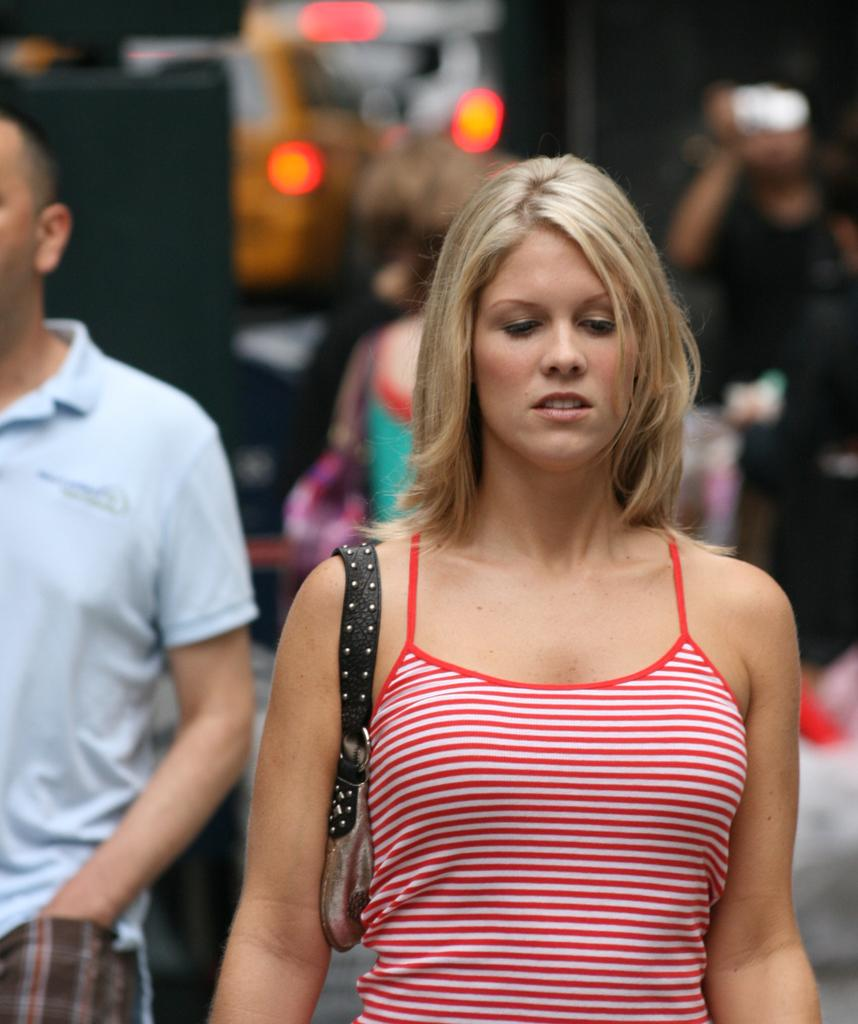Who is present in the image? There is a woman and a man in the image. What is the woman wearing? The woman is wearing a red dress. What is the man wearing? The man is wearing a blue color T-shirt. What is the woman doing in the image? The woman is walking. How is the background of the image? The background of the image is blurred. What type of cream can be seen on the woman's face in the image? There is no cream visible on the woman's face in the image. How does the man show respect to the woman in the image? There is no indication of the man showing respect to the woman in the image. 